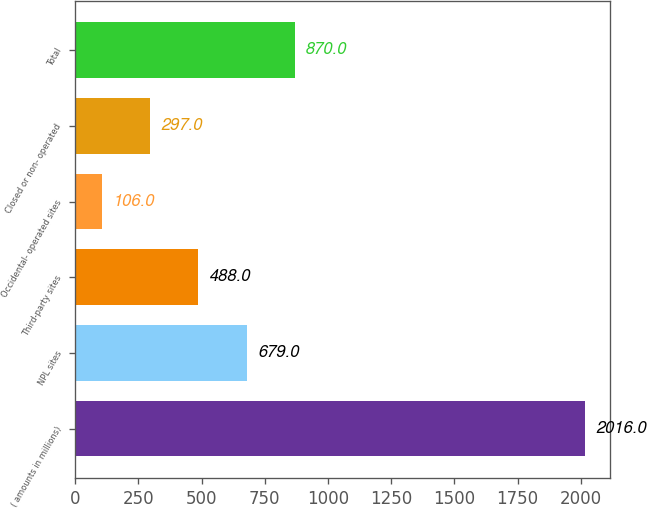Convert chart. <chart><loc_0><loc_0><loc_500><loc_500><bar_chart><fcel>( amounts in millions)<fcel>NPL sites<fcel>Third-party sites<fcel>Occidental- operated sites<fcel>Closed or non- operated<fcel>Total<nl><fcel>2016<fcel>679<fcel>488<fcel>106<fcel>297<fcel>870<nl></chart> 